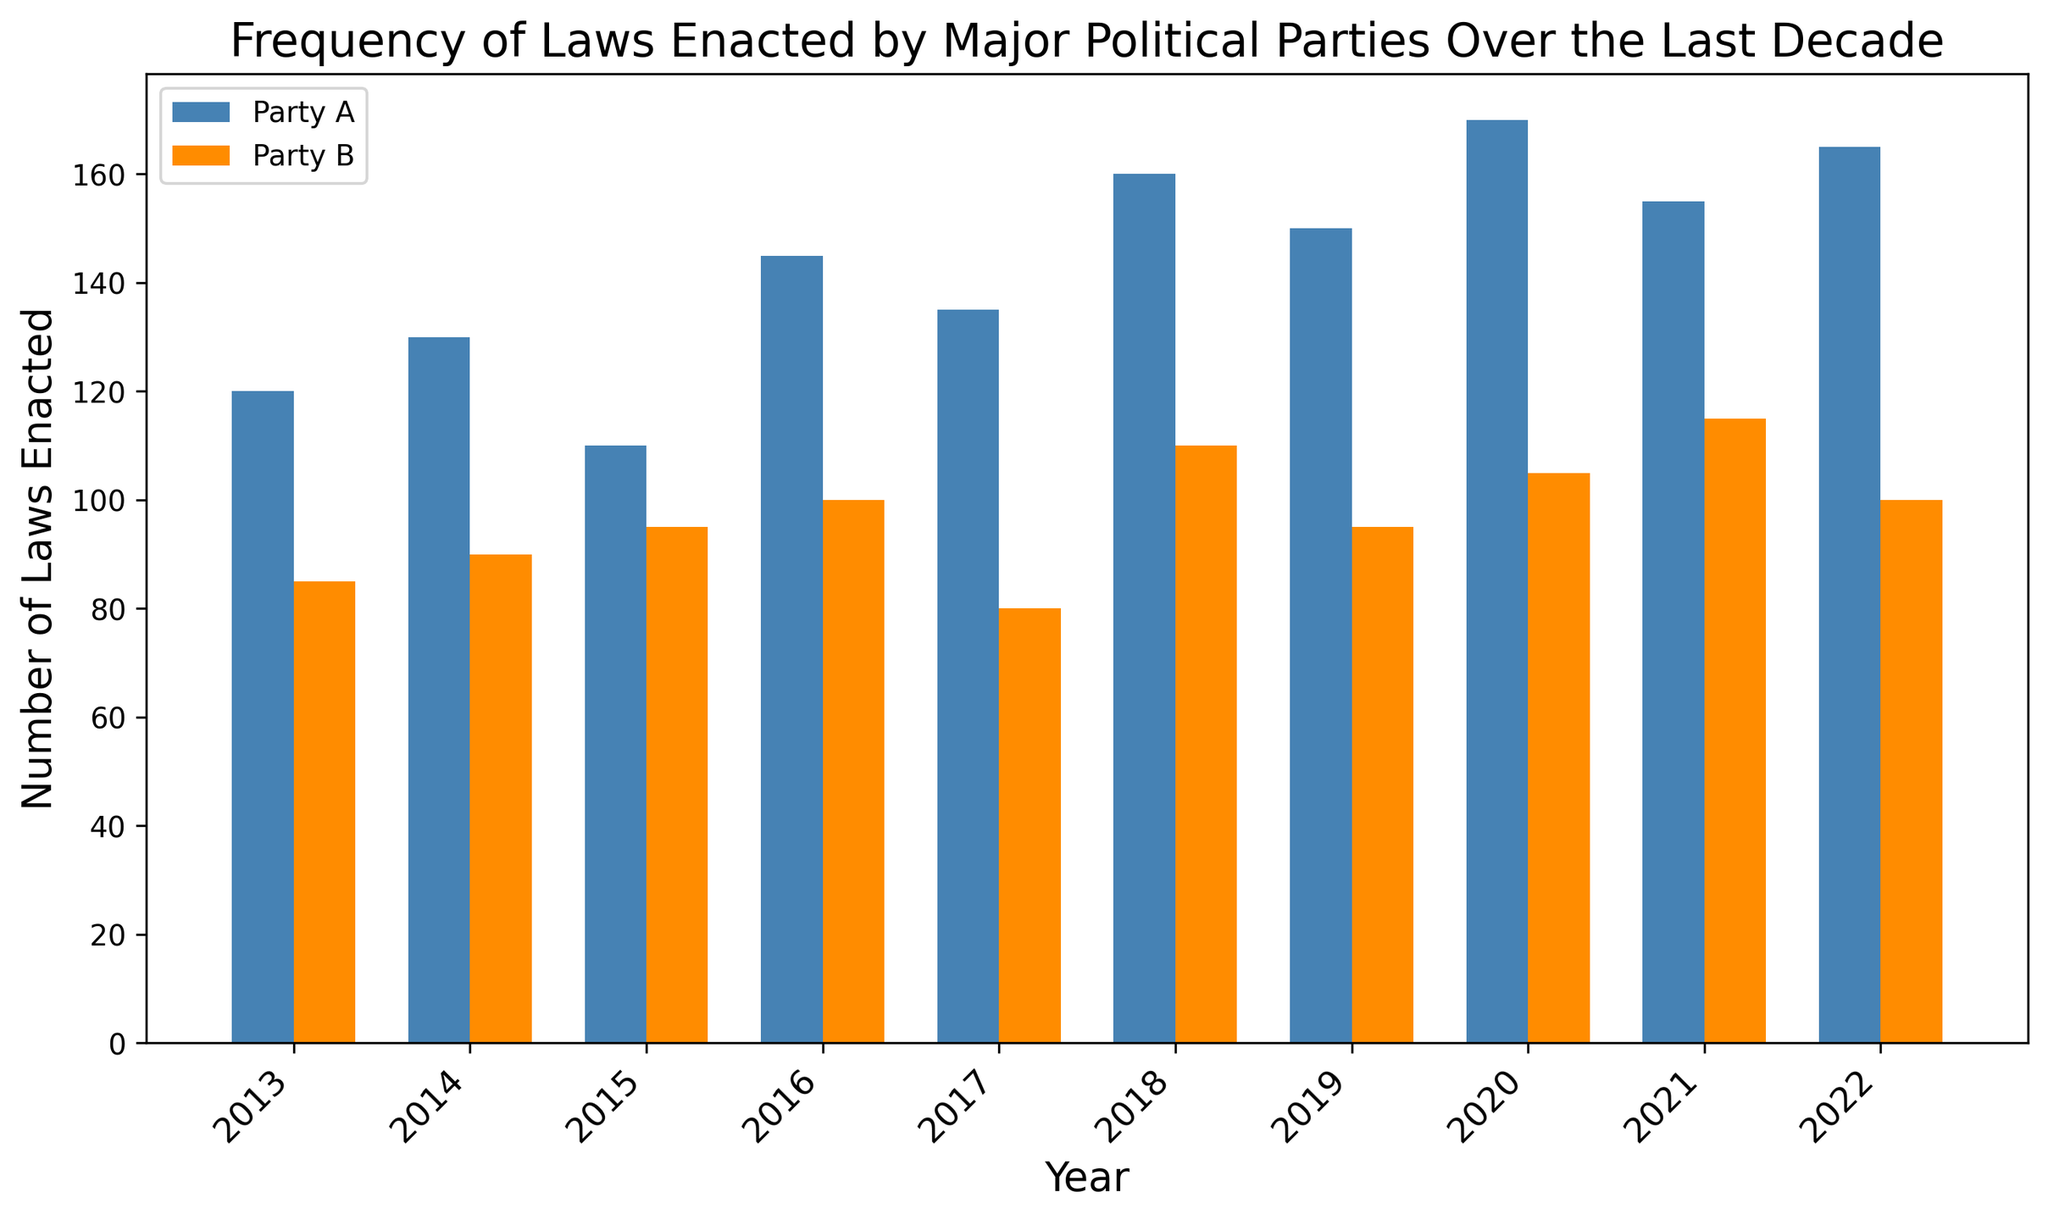What is the total number of laws enacted by Party A in the year 2018? To determine the total number of laws enacted by Party A in 2018, look at the height of the bar corresponding to Party A for the year 2018. According to the data, Party A enacted 160 laws in 2018.
Answer: 160 Which year did Party B enact the fewest laws and how many laws were enacted that year? To find the year when Party B enacted the fewest laws, compare the heights of all bars associated with Party B over the years. The smallest bar is in the year 2017, where Party B enacted 80 laws.
Answer: 2017, 80 How many more laws did Party A enact than Party B in the year 2016? To determine the difference, find the number of laws enacted by Party A (145) and by Party B (100) in 2016, then calculate the difference: 145 - 100 = 45.
Answer: 45 Compare the average number of laws enacted per year by Party A and Party B over the decade. Which party enacted more on average? Calculate the total number of laws enacted by each party over the decade, then divide by the number of years (10). Party A total = 1340, Party B total = 975. Average for Party A = 1340/10 = 134, average for Party B = 975/10 = 97.5. Party A enacted more on average.
Answer: Party A In which year did both parties enact a combined total of 265 laws? To find this, add the number of laws enacted by both parties for each year and identify the year that totals 265. In 2014, Party A enacted 130 and Party B enacted 90, combining to 220 laws. The year 2018 has Party A enacting 160 and Party B enacting 110, resulting in a total of 270. In 2022, Party A enacted 165 and Party B enacted 100, totaling 265.
Answer: 2022 What was the most significant increase in the number of laws enacted by Party A from one year to the next? To find the most significant increase, look at the differences year over year. The increases are: 10 (2014-2013), -20 (2015-2014), 35 (2016-2015), -10 (2017-2016), 25 (2018-2017), -10 (2019-2018), 20 (2020-2019), -15 (2021-2020), 10 (2022-2021). The largest increase is 35 from 2015 to 2016.
Answer: 35 (2015 to 2016) Which party showed a more consistent trend in the number of laws enacted over the decade? A consistent trend means fewer fluctuations in the number of laws enacted year over year. By observing the changes in the heights of the bars, Party B shows smaller variations in the height of its bars across the years compared to Party A.
Answer: Party B What was the difference in the total number of laws enacted between Party A and Party B over the decade? Calculate the total for each party over the decade and find the difference: Total for Party A = 1340, Total for Party B = 975. Difference = 1340 - 975 = 365.
Answer: 365 Was there any year where both parties enacted the same number of laws? Look at each pair of bars for every year and compare their heights. No year has bars of equal height, thus no year had the same number of laws enacted by both parties.
Answer: No How many years did Party B enact more than 100 laws? Count the number of years the height of Party B's bars exceeds 100. This occurred in 2018, 2020, and 2021.
Answer: 3 years 